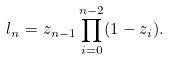<formula> <loc_0><loc_0><loc_500><loc_500>l _ { n } = z _ { n - 1 } \prod _ { i = 0 } ^ { n - 2 } ( 1 - z _ { i } ) .</formula> 